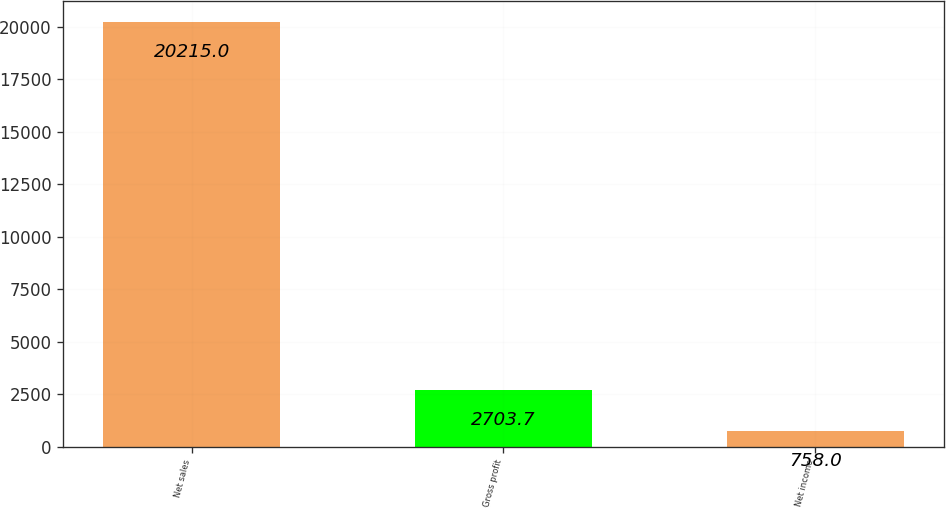<chart> <loc_0><loc_0><loc_500><loc_500><bar_chart><fcel>Net sales<fcel>Gross profit<fcel>Net income<nl><fcel>20215<fcel>2703.7<fcel>758<nl></chart> 